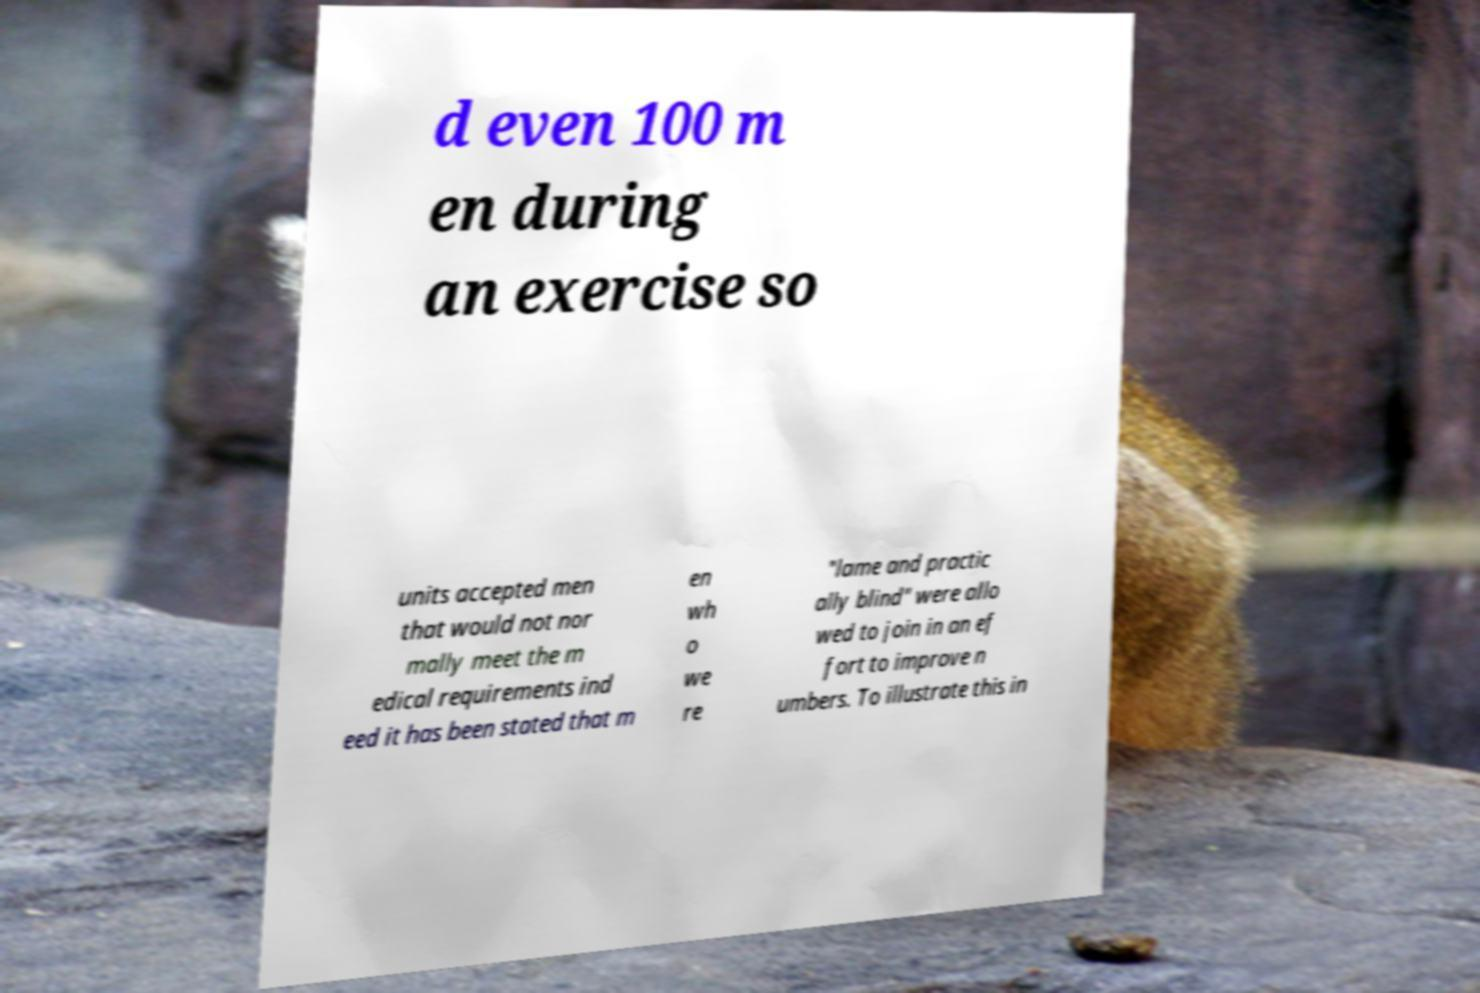Please read and relay the text visible in this image. What does it say? d even 100 m en during an exercise so units accepted men that would not nor mally meet the m edical requirements ind eed it has been stated that m en wh o we re "lame and practic ally blind" were allo wed to join in an ef fort to improve n umbers. To illustrate this in 